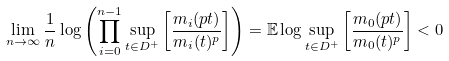Convert formula to latex. <formula><loc_0><loc_0><loc_500><loc_500>\lim _ { n \rightarrow \infty } \frac { 1 } { n } \log \left ( \prod _ { i = 0 } ^ { n - 1 } \sup _ { t \in D ^ { + } } \left [ \frac { m _ { i } ( p t ) } { m _ { i } ( t ) ^ { p } } \right ] \right ) = \mathbb { E } \log \sup _ { t \in D ^ { + } } \left [ \frac { m _ { 0 } ( p t ) } { m _ { 0 } ( t ) ^ { p } } \right ] < 0</formula> 